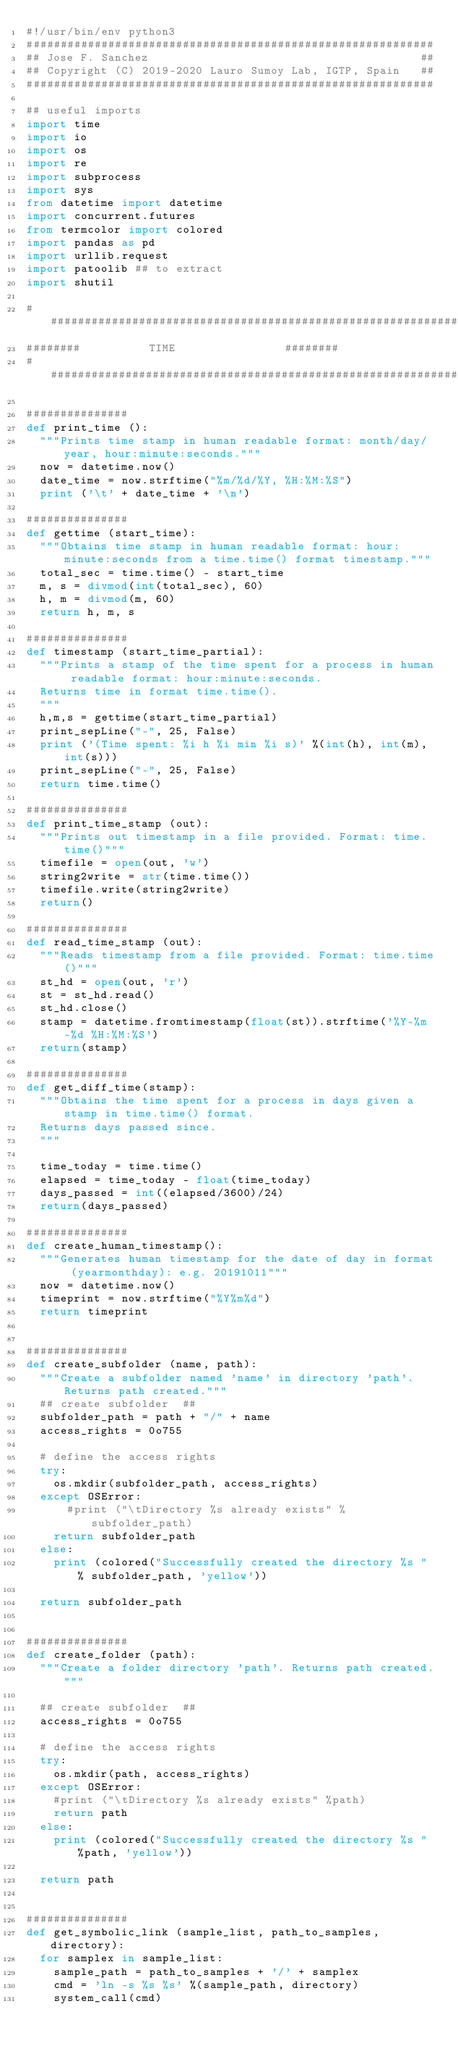Convert code to text. <code><loc_0><loc_0><loc_500><loc_500><_Python_>#!/usr/bin/env python3
############################################################
## Jose F. Sanchez                                        ##
## Copyright (C) 2019-2020 Lauro Sumoy Lab, IGTP, Spain   ##
############################################################

## useful imports
import time
import io
import os
import re
import subprocess
import sys
from datetime import datetime
import concurrent.futures
from termcolor import colored
import pandas as pd
import urllib.request
import patoolib ## to extract
import shutil

########################################################################
######## 					TIME								######## 					
########################################################################

###############   
def print_time ():
	"""Prints time stamp in human readable format: month/day/year, hour:minute:seconds."""
	now = datetime.now()
	date_time = now.strftime("%m/%d/%Y, %H:%M:%S")
	print ('\t' + date_time + '\n')

###############   
def gettime (start_time):
	"""Obtains time stamp in human readable format: hour:minute:seconds from a time.time() format timestamp."""
	total_sec = time.time() - start_time
	m, s = divmod(int(total_sec), 60)
	h, m = divmod(m, 60)
	return h, m, s

###############	
def timestamp (start_time_partial):
	"""Prints a stamp of the time spent for a process in human readable format: hour:minute:seconds.
	Returns time in format time.time().
	"""
	h,m,s = gettime(start_time_partial)
	print_sepLine("-", 25, False)
	print ('(Time spent: %i h %i min %i s)' %(int(h), int(m), int(s)))
	print_sepLine("-", 25, False)
	return time.time()

###############	
def print_time_stamp (out):
	"""Prints out timestamp in a file provided. Format: time.time()"""
	timefile = open(out, 'w')    
	string2write = str(time.time())
	timefile.write(string2write)
	return()

###############	
def read_time_stamp (out):
	"""Reads timestamp from a file provided. Format: time.time()"""
	st_hd = open(out, 'r')
	st = st_hd.read()
	st_hd.close()
	stamp = datetime.fromtimestamp(float(st)).strftime('%Y-%m-%d %H:%M:%S')
	return(stamp)

###############	
def get_diff_time(stamp):
	"""Obtains the time spent for a process in days given a stamp in time.time() format.
	Returns days passed since.
	"""

	time_today = time.time()
	elapsed = time_today - float(time_today)
	days_passed = int((elapsed/3600)/24)
	return(days_passed)

###############    
def create_human_timestamp():
	"""Generates human timestamp for the date of day in format (yearmonthday): e.g. 20191011"""
	now = datetime.now()
	timeprint = now.strftime("%Y%m%d")
	return timeprint


###############
def create_subfolder (name, path):
	"""Create a subfolder named 'name' in directory 'path'. Returns path created."""
	## create subfolder  ##	
	subfolder_path = path + "/" + name
	access_rights = 0o755

	# define the access rights
	try:
		os.mkdir(subfolder_path, access_rights)
	except OSError:  
	   	#print ("\tDirectory %s already exists" % subfolder_path)
		return subfolder_path
	else:  
		print (colored("Successfully created the directory %s " % subfolder_path, 'yellow'))

	return subfolder_path

    
###############  
def create_folder (path):
	"""Create a folder directory 'path'. Returns path created."""

	## create subfolder  ##	
	access_rights = 0o755

	# define the access rights
	try:
		os.mkdir(path, access_rights)
	except OSError:  
		#print ("\tDirectory %s already exists" %path)
		return path
	else:  
		print (colored("Successfully created the directory %s " %path, 'yellow'))

	return path


############### 
def get_symbolic_link (sample_list, path_to_samples, directory):
	for samplex in sample_list:
		sample_path = path_to_samples + '/' + samplex
		cmd = 'ln -s %s %s' %(sample_path, directory)
		system_call(cmd)
</code> 